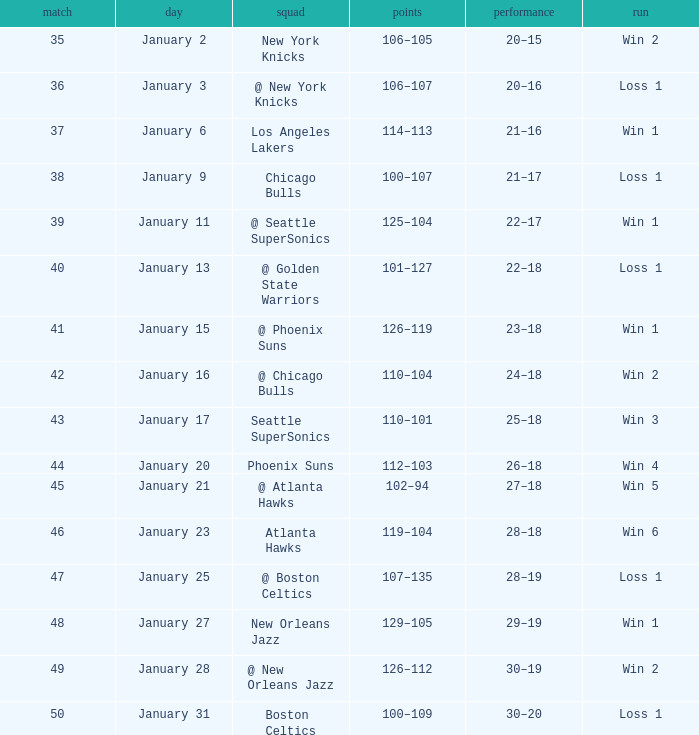What is the Team in Game 38? Chicago Bulls. 